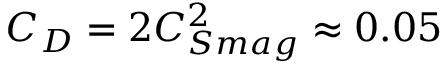<formula> <loc_0><loc_0><loc_500><loc_500>C _ { D } = 2 C _ { S m a g } ^ { 2 } \approx 0 . 0 5</formula> 